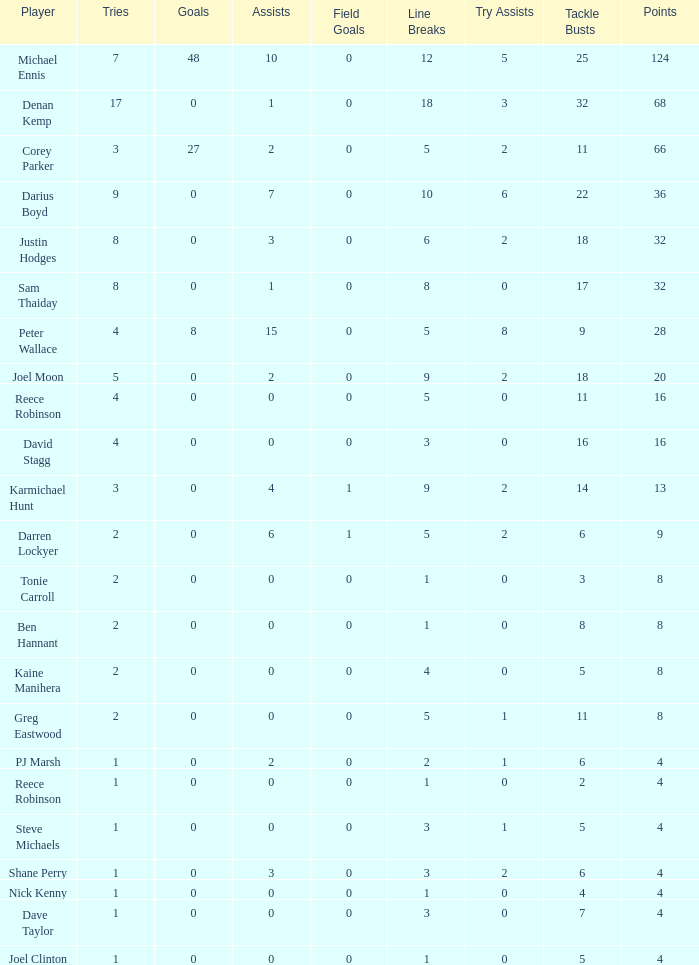How many points did the player with 2 tries and more than 0 field goals have? 9.0. Write the full table. {'header': ['Player', 'Tries', 'Goals', 'Assists', 'Field Goals', 'Line Breaks', 'Try Assists', 'Tackle Busts', 'Points'], 'rows': [['Michael Ennis', '7', '48', '10', '0', '12', '5', '25', '124'], ['Denan Kemp', '17', '0', '1', '0', '18', '3', '32', '68'], ['Corey Parker', '3', '27', '2', '0', '5', '2', '11', '66'], ['Darius Boyd', '9', '0', '7', '0', '10', '6', '22', '36'], ['Justin Hodges', '8', '0', '3', '0', '6', '2', '18', '32'], ['Sam Thaiday', '8', '0', '1', '0', '8', '0', '17', '32'], ['Peter Wallace', '4', '8', '15', '0', '5', '8', '9', '28'], ['Joel Moon', '5', '0', '2', '0', '9', '2', '18', '20'], ['Reece Robinson', '4', '0', '0', '0', '5', '0', '11', '16'], ['David Stagg', '4', '0', '0', '0', '3', '0', '16', '16'], ['Karmichael Hunt', '3', '0', '4', '1', '9', '2', '14', '13'], ['Darren Lockyer', '2', '0', '6', '1', '5', '2', '6', '9'], ['Tonie Carroll', '2', '0', '0', '0', '1', '0', '3', '8'], ['Ben Hannant', '2', '0', '0', '0', '1', '0', '8', '8'], ['Kaine Manihera', '2', '0', '0', '0', '4', '0', '5', '8'], ['Greg Eastwood', '2', '0', '0', '0', '5', '1', '11', '8'], ['PJ Marsh', '1', '0', '2', '0', '2', '1', '6', '4'], ['Reece Robinson', '1', '0', '0', '0', '1', '0', '2', '4'], ['Steve Michaels', '1', '0', '0', '0', '3', '1', '5', '4'], ['Shane Perry', '1', '0', '3', '0', '3', '2', '6', '4'], ['Nick Kenny', '1', '0', '0', '0', '1', '0', '4', '4'], ['Dave Taylor', '1', '0', '0', '0', '3', '0', '7', '4'], ['Joel Clinton', '1', '0', '0', '0', '1', '0', '5', '4']]} 